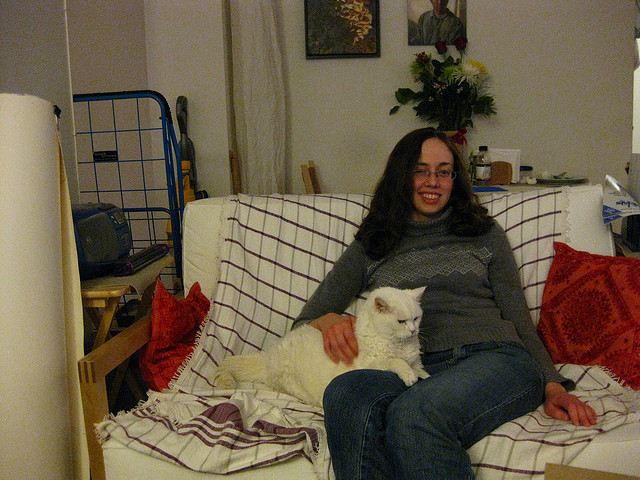Please extract the text content from this image. M 